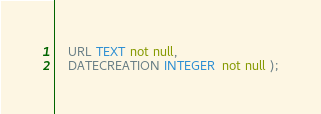<code> <loc_0><loc_0><loc_500><loc_500><_SQL_>	URL TEXT not null,
	DATECREATION INTEGER  not null );

</code> 